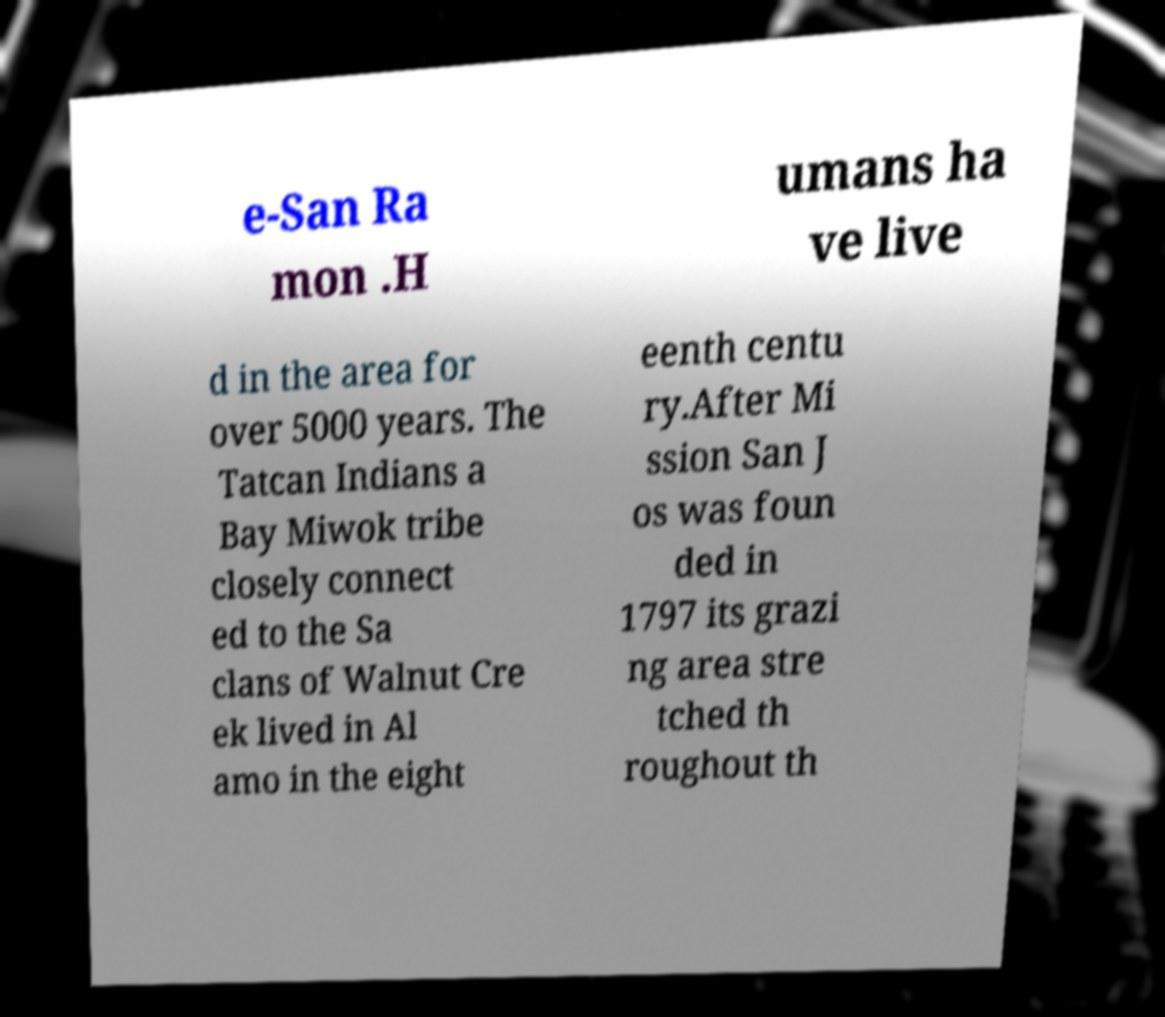What messages or text are displayed in this image? I need them in a readable, typed format. e-San Ra mon .H umans ha ve live d in the area for over 5000 years. The Tatcan Indians a Bay Miwok tribe closely connect ed to the Sa clans of Walnut Cre ek lived in Al amo in the eight eenth centu ry.After Mi ssion San J os was foun ded in 1797 its grazi ng area stre tched th roughout th 